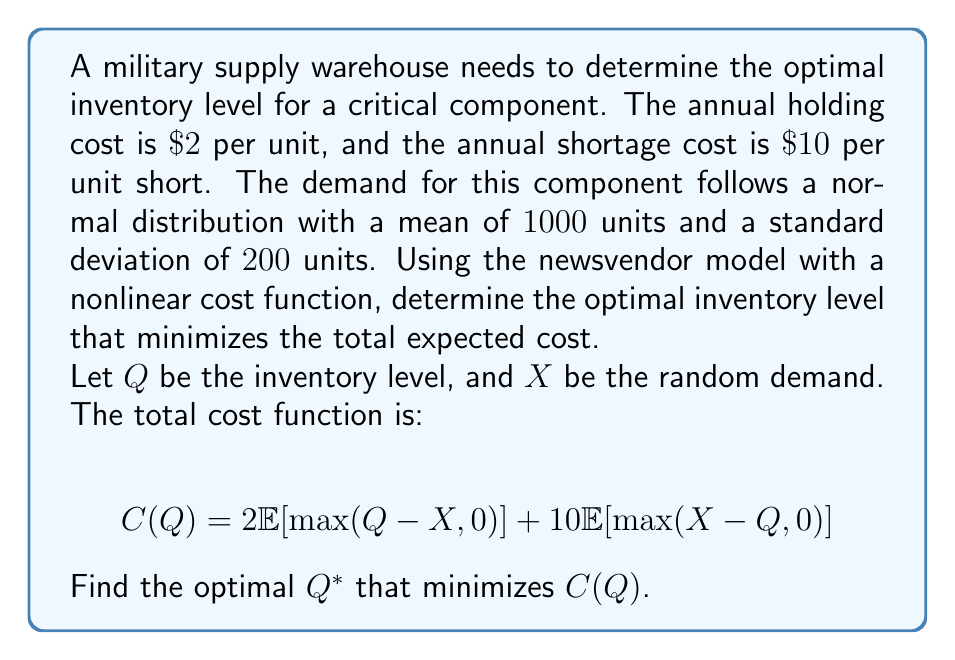Provide a solution to this math problem. To solve this problem, we'll follow these steps:

1) In the newsvendor model with normal demand, the optimal inventory level $Q^*$ is given by the inverse cumulative distribution function (CDF) of the demand at the critical fractile.

2) The critical fractile is determined by the ratio of the shortage cost to the sum of holding and shortage costs:

   Critical fractile = $\frac{p}{p+h} = \frac{10}{10+2} = \frac{5}{6} \approx 0.8333$

   Where $p=10$ is the shortage cost and $h=2$ is the holding cost.

3) For a normal distribution with mean $\mu=1000$ and standard deviation $\sigma=200$, we need to find $Q^*$ such that:

   $P(X \leq Q^*) = 0.8333$

4) This can be expressed in terms of the standard normal distribution $Z$:

   $P(Z \leq \frac{Q^*-\mu}{\sigma}) = 0.8333$

5) From the standard normal table, we find that the z-score corresponding to 0.8333 is approximately 0.97.

6) Therefore:

   $\frac{Q^*-1000}{200} = 0.97$

7) Solving for $Q^*$:

   $Q^* = 1000 + (0.97 * 200) = 1194$

8) Rounding to the nearest whole number (as we can't have fractional inventory):

   $Q^* = 1194$ units
Answer: 1194 units 